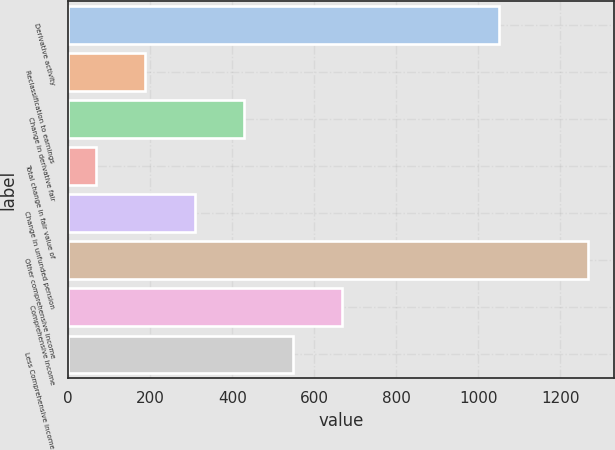<chart> <loc_0><loc_0><loc_500><loc_500><bar_chart><fcel>Derivative activity<fcel>Reclassification to earnings<fcel>Change in derivative fair<fcel>Total change in fair value of<fcel>Change in unfunded pension<fcel>Other comprehensive income<fcel>Comprehensive income<fcel>Less Comprehensive income<nl><fcel>1052<fcel>188.1<fcel>428.3<fcel>68<fcel>308.2<fcel>1269<fcel>668.5<fcel>548.4<nl></chart> 